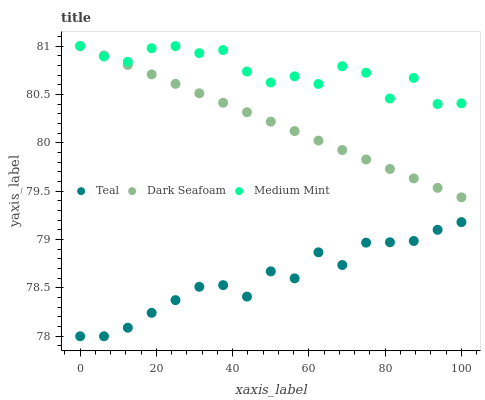Does Teal have the minimum area under the curve?
Answer yes or no. Yes. Does Medium Mint have the maximum area under the curve?
Answer yes or no. Yes. Does Dark Seafoam have the minimum area under the curve?
Answer yes or no. No. Does Dark Seafoam have the maximum area under the curve?
Answer yes or no. No. Is Dark Seafoam the smoothest?
Answer yes or no. Yes. Is Medium Mint the roughest?
Answer yes or no. Yes. Is Teal the smoothest?
Answer yes or no. No. Is Teal the roughest?
Answer yes or no. No. Does Teal have the lowest value?
Answer yes or no. Yes. Does Dark Seafoam have the lowest value?
Answer yes or no. No. Does Dark Seafoam have the highest value?
Answer yes or no. Yes. Does Teal have the highest value?
Answer yes or no. No. Is Teal less than Dark Seafoam?
Answer yes or no. Yes. Is Dark Seafoam greater than Teal?
Answer yes or no. Yes. Does Dark Seafoam intersect Medium Mint?
Answer yes or no. Yes. Is Dark Seafoam less than Medium Mint?
Answer yes or no. No. Is Dark Seafoam greater than Medium Mint?
Answer yes or no. No. Does Teal intersect Dark Seafoam?
Answer yes or no. No. 